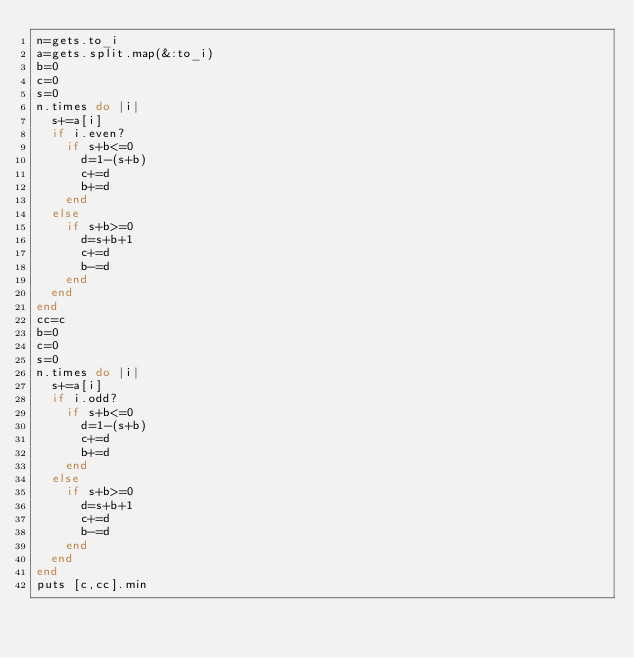Convert code to text. <code><loc_0><loc_0><loc_500><loc_500><_Ruby_>n=gets.to_i
a=gets.split.map(&:to_i)
b=0
c=0
s=0
n.times do |i|
  s+=a[i]
  if i.even?
    if s+b<=0
      d=1-(s+b)
      c+=d
      b+=d
    end
  else
    if s+b>=0
      d=s+b+1
      c+=d
      b-=d
    end
  end
end
cc=c
b=0
c=0
s=0
n.times do |i|
  s+=a[i]
  if i.odd?
    if s+b<=0
      d=1-(s+b)
      c+=d
      b+=d
    end
  else
    if s+b>=0
      d=s+b+1
      c+=d
      b-=d
    end
  end
end
puts [c,cc].min
</code> 